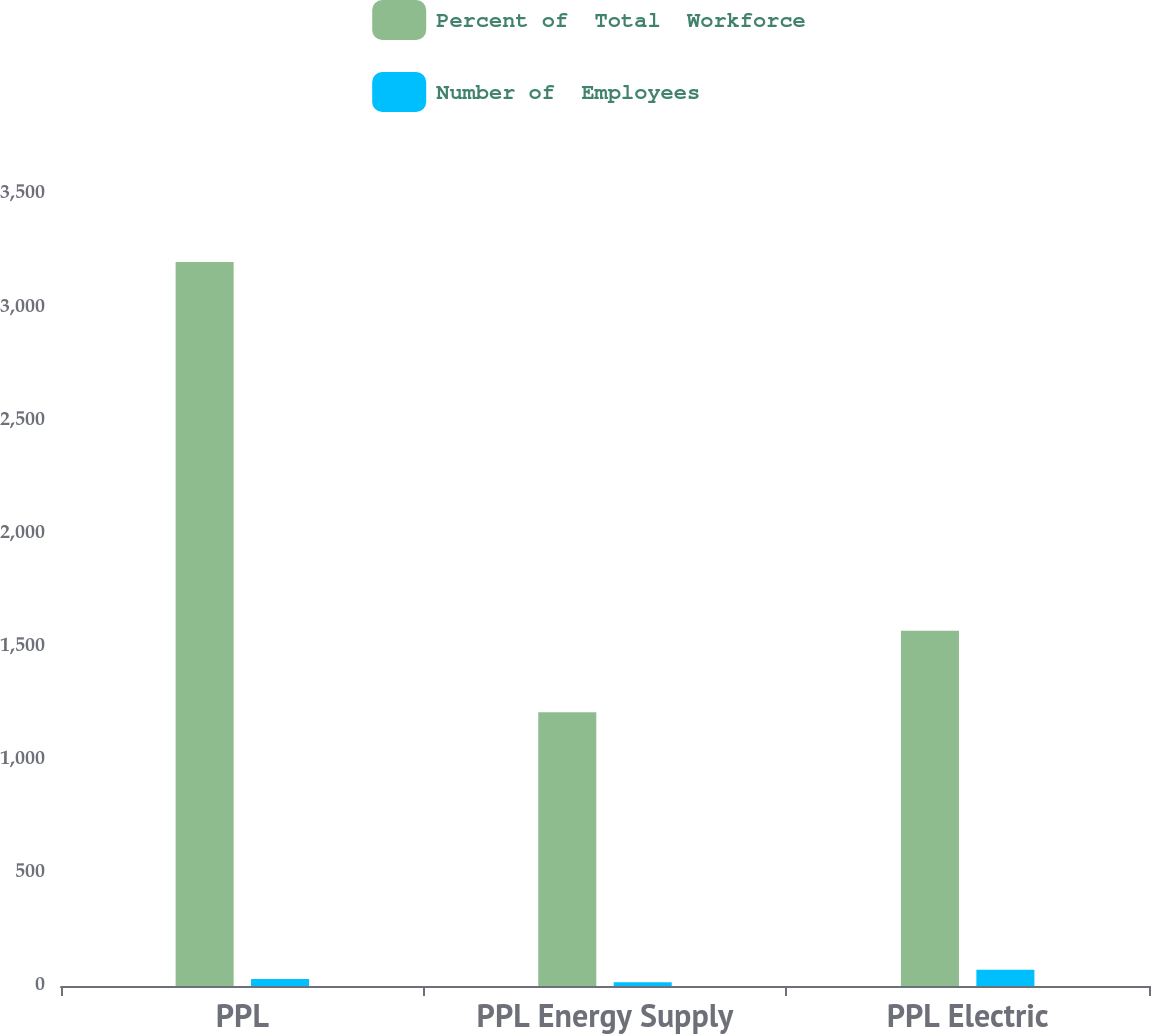<chart> <loc_0><loc_0><loc_500><loc_500><stacked_bar_chart><ecel><fcel>PPL<fcel>PPL Energy Supply<fcel>PPL Electric<nl><fcel>Percent of  Total  Workforce<fcel>3200<fcel>1210<fcel>1570<nl><fcel>Number of  Employees<fcel>31<fcel>17<fcel>72<nl></chart> 